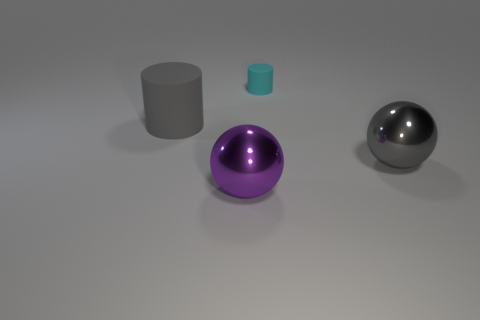Is there anything else that has the same size as the cyan matte cylinder?
Make the answer very short. No. What is the material of the large sphere that is the same color as the big matte object?
Provide a succinct answer. Metal. There is a thing to the left of the large purple sphere; is it the same size as the matte cylinder that is to the right of the large gray rubber thing?
Ensure brevity in your answer.  No. How many green objects are rubber cylinders or small matte objects?
Offer a very short reply. 0. There is a sphere that is the same color as the big matte object; what size is it?
Make the answer very short. Large. Are there more brown cylinders than big gray balls?
Your answer should be very brief. No. How many objects are either big cyan rubber things or objects that are left of the tiny cyan object?
Make the answer very short. 2. How many other objects are the same shape as the large gray metal object?
Offer a very short reply. 1. Are there fewer shiny things left of the tiny cyan rubber cylinder than matte cylinders behind the large purple thing?
Offer a very short reply. Yes. The tiny cyan thing that is made of the same material as the gray cylinder is what shape?
Keep it short and to the point. Cylinder. 